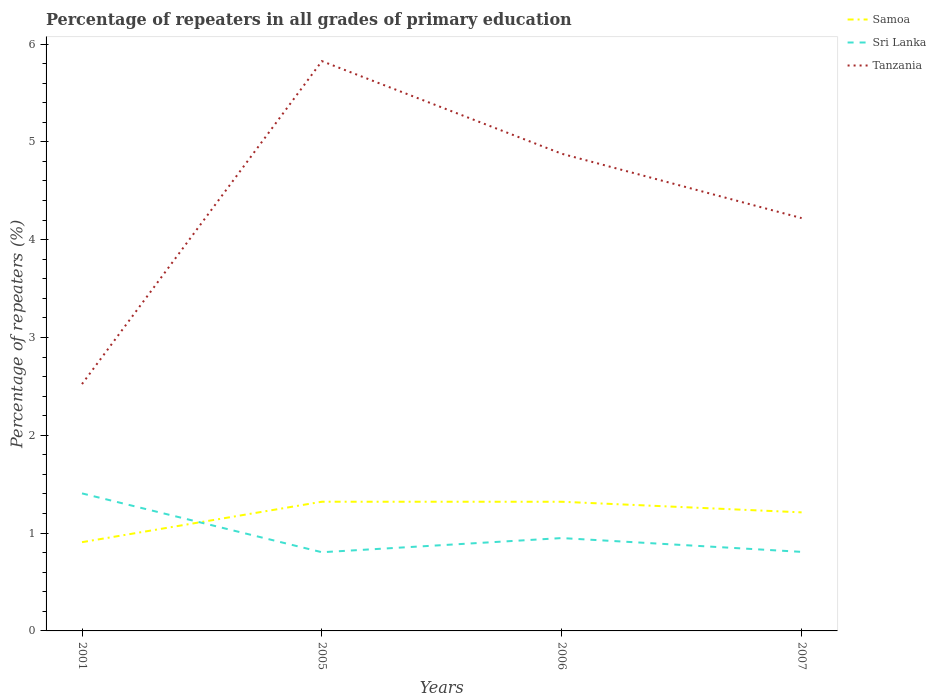How many different coloured lines are there?
Provide a short and direct response. 3. Across all years, what is the maximum percentage of repeaters in Sri Lanka?
Your answer should be very brief. 0.8. In which year was the percentage of repeaters in Samoa maximum?
Provide a succinct answer. 2001. What is the total percentage of repeaters in Tanzania in the graph?
Ensure brevity in your answer.  -1.7. What is the difference between the highest and the second highest percentage of repeaters in Sri Lanka?
Ensure brevity in your answer.  0.6. How many lines are there?
Make the answer very short. 3. How many years are there in the graph?
Your response must be concise. 4. What is the difference between two consecutive major ticks on the Y-axis?
Make the answer very short. 1. Does the graph contain grids?
Offer a terse response. No. How many legend labels are there?
Your answer should be very brief. 3. How are the legend labels stacked?
Your response must be concise. Vertical. What is the title of the graph?
Your answer should be very brief. Percentage of repeaters in all grades of primary education. Does "Guyana" appear as one of the legend labels in the graph?
Provide a short and direct response. No. What is the label or title of the X-axis?
Give a very brief answer. Years. What is the label or title of the Y-axis?
Ensure brevity in your answer.  Percentage of repeaters (%). What is the Percentage of repeaters (%) of Samoa in 2001?
Provide a short and direct response. 0.91. What is the Percentage of repeaters (%) of Sri Lanka in 2001?
Provide a succinct answer. 1.41. What is the Percentage of repeaters (%) in Tanzania in 2001?
Provide a short and direct response. 2.52. What is the Percentage of repeaters (%) in Samoa in 2005?
Ensure brevity in your answer.  1.32. What is the Percentage of repeaters (%) of Sri Lanka in 2005?
Make the answer very short. 0.8. What is the Percentage of repeaters (%) of Tanzania in 2005?
Make the answer very short. 5.83. What is the Percentage of repeaters (%) of Samoa in 2006?
Make the answer very short. 1.32. What is the Percentage of repeaters (%) of Sri Lanka in 2006?
Give a very brief answer. 0.95. What is the Percentage of repeaters (%) in Tanzania in 2006?
Ensure brevity in your answer.  4.88. What is the Percentage of repeaters (%) in Samoa in 2007?
Your response must be concise. 1.21. What is the Percentage of repeaters (%) in Sri Lanka in 2007?
Make the answer very short. 0.81. What is the Percentage of repeaters (%) in Tanzania in 2007?
Your answer should be compact. 4.22. Across all years, what is the maximum Percentage of repeaters (%) in Samoa?
Your answer should be very brief. 1.32. Across all years, what is the maximum Percentage of repeaters (%) of Sri Lanka?
Give a very brief answer. 1.41. Across all years, what is the maximum Percentage of repeaters (%) of Tanzania?
Ensure brevity in your answer.  5.83. Across all years, what is the minimum Percentage of repeaters (%) of Samoa?
Make the answer very short. 0.91. Across all years, what is the minimum Percentage of repeaters (%) in Sri Lanka?
Make the answer very short. 0.8. Across all years, what is the minimum Percentage of repeaters (%) in Tanzania?
Your answer should be very brief. 2.52. What is the total Percentage of repeaters (%) in Samoa in the graph?
Keep it short and to the point. 4.76. What is the total Percentage of repeaters (%) in Sri Lanka in the graph?
Your answer should be very brief. 3.97. What is the total Percentage of repeaters (%) of Tanzania in the graph?
Your answer should be very brief. 17.45. What is the difference between the Percentage of repeaters (%) in Samoa in 2001 and that in 2005?
Make the answer very short. -0.41. What is the difference between the Percentage of repeaters (%) of Sri Lanka in 2001 and that in 2005?
Your answer should be compact. 0.6. What is the difference between the Percentage of repeaters (%) of Tanzania in 2001 and that in 2005?
Provide a short and direct response. -3.3. What is the difference between the Percentage of repeaters (%) of Samoa in 2001 and that in 2006?
Provide a short and direct response. -0.41. What is the difference between the Percentage of repeaters (%) in Sri Lanka in 2001 and that in 2006?
Ensure brevity in your answer.  0.46. What is the difference between the Percentage of repeaters (%) in Tanzania in 2001 and that in 2006?
Offer a terse response. -2.35. What is the difference between the Percentage of repeaters (%) in Samoa in 2001 and that in 2007?
Give a very brief answer. -0.3. What is the difference between the Percentage of repeaters (%) of Sri Lanka in 2001 and that in 2007?
Provide a succinct answer. 0.6. What is the difference between the Percentage of repeaters (%) in Tanzania in 2001 and that in 2007?
Keep it short and to the point. -1.7. What is the difference between the Percentage of repeaters (%) of Samoa in 2005 and that in 2006?
Provide a succinct answer. 0. What is the difference between the Percentage of repeaters (%) of Sri Lanka in 2005 and that in 2006?
Offer a very short reply. -0.14. What is the difference between the Percentage of repeaters (%) in Tanzania in 2005 and that in 2006?
Ensure brevity in your answer.  0.95. What is the difference between the Percentage of repeaters (%) of Samoa in 2005 and that in 2007?
Make the answer very short. 0.11. What is the difference between the Percentage of repeaters (%) of Sri Lanka in 2005 and that in 2007?
Offer a very short reply. -0. What is the difference between the Percentage of repeaters (%) of Tanzania in 2005 and that in 2007?
Give a very brief answer. 1.6. What is the difference between the Percentage of repeaters (%) of Samoa in 2006 and that in 2007?
Give a very brief answer. 0.11. What is the difference between the Percentage of repeaters (%) of Sri Lanka in 2006 and that in 2007?
Provide a short and direct response. 0.14. What is the difference between the Percentage of repeaters (%) of Tanzania in 2006 and that in 2007?
Make the answer very short. 0.66. What is the difference between the Percentage of repeaters (%) of Samoa in 2001 and the Percentage of repeaters (%) of Sri Lanka in 2005?
Make the answer very short. 0.1. What is the difference between the Percentage of repeaters (%) in Samoa in 2001 and the Percentage of repeaters (%) in Tanzania in 2005?
Keep it short and to the point. -4.92. What is the difference between the Percentage of repeaters (%) in Sri Lanka in 2001 and the Percentage of repeaters (%) in Tanzania in 2005?
Your answer should be compact. -4.42. What is the difference between the Percentage of repeaters (%) of Samoa in 2001 and the Percentage of repeaters (%) of Sri Lanka in 2006?
Offer a terse response. -0.04. What is the difference between the Percentage of repeaters (%) in Samoa in 2001 and the Percentage of repeaters (%) in Tanzania in 2006?
Provide a succinct answer. -3.97. What is the difference between the Percentage of repeaters (%) of Sri Lanka in 2001 and the Percentage of repeaters (%) of Tanzania in 2006?
Keep it short and to the point. -3.47. What is the difference between the Percentage of repeaters (%) of Samoa in 2001 and the Percentage of repeaters (%) of Sri Lanka in 2007?
Your response must be concise. 0.1. What is the difference between the Percentage of repeaters (%) of Samoa in 2001 and the Percentage of repeaters (%) of Tanzania in 2007?
Keep it short and to the point. -3.31. What is the difference between the Percentage of repeaters (%) of Sri Lanka in 2001 and the Percentage of repeaters (%) of Tanzania in 2007?
Make the answer very short. -2.81. What is the difference between the Percentage of repeaters (%) in Samoa in 2005 and the Percentage of repeaters (%) in Sri Lanka in 2006?
Ensure brevity in your answer.  0.37. What is the difference between the Percentage of repeaters (%) of Samoa in 2005 and the Percentage of repeaters (%) of Tanzania in 2006?
Give a very brief answer. -3.56. What is the difference between the Percentage of repeaters (%) in Sri Lanka in 2005 and the Percentage of repeaters (%) in Tanzania in 2006?
Offer a very short reply. -4.07. What is the difference between the Percentage of repeaters (%) of Samoa in 2005 and the Percentage of repeaters (%) of Sri Lanka in 2007?
Give a very brief answer. 0.51. What is the difference between the Percentage of repeaters (%) of Samoa in 2005 and the Percentage of repeaters (%) of Tanzania in 2007?
Offer a very short reply. -2.9. What is the difference between the Percentage of repeaters (%) in Sri Lanka in 2005 and the Percentage of repeaters (%) in Tanzania in 2007?
Offer a very short reply. -3.42. What is the difference between the Percentage of repeaters (%) in Samoa in 2006 and the Percentage of repeaters (%) in Sri Lanka in 2007?
Provide a short and direct response. 0.51. What is the difference between the Percentage of repeaters (%) in Samoa in 2006 and the Percentage of repeaters (%) in Tanzania in 2007?
Offer a terse response. -2.9. What is the difference between the Percentage of repeaters (%) of Sri Lanka in 2006 and the Percentage of repeaters (%) of Tanzania in 2007?
Provide a succinct answer. -3.27. What is the average Percentage of repeaters (%) in Samoa per year?
Offer a terse response. 1.19. What is the average Percentage of repeaters (%) in Sri Lanka per year?
Offer a very short reply. 0.99. What is the average Percentage of repeaters (%) of Tanzania per year?
Your answer should be compact. 4.36. In the year 2001, what is the difference between the Percentage of repeaters (%) of Samoa and Percentage of repeaters (%) of Sri Lanka?
Offer a very short reply. -0.5. In the year 2001, what is the difference between the Percentage of repeaters (%) in Samoa and Percentage of repeaters (%) in Tanzania?
Ensure brevity in your answer.  -1.62. In the year 2001, what is the difference between the Percentage of repeaters (%) of Sri Lanka and Percentage of repeaters (%) of Tanzania?
Provide a succinct answer. -1.12. In the year 2005, what is the difference between the Percentage of repeaters (%) in Samoa and Percentage of repeaters (%) in Sri Lanka?
Offer a terse response. 0.52. In the year 2005, what is the difference between the Percentage of repeaters (%) in Samoa and Percentage of repeaters (%) in Tanzania?
Provide a succinct answer. -4.5. In the year 2005, what is the difference between the Percentage of repeaters (%) in Sri Lanka and Percentage of repeaters (%) in Tanzania?
Give a very brief answer. -5.02. In the year 2006, what is the difference between the Percentage of repeaters (%) in Samoa and Percentage of repeaters (%) in Sri Lanka?
Give a very brief answer. 0.37. In the year 2006, what is the difference between the Percentage of repeaters (%) of Samoa and Percentage of repeaters (%) of Tanzania?
Make the answer very short. -3.56. In the year 2006, what is the difference between the Percentage of repeaters (%) of Sri Lanka and Percentage of repeaters (%) of Tanzania?
Offer a very short reply. -3.93. In the year 2007, what is the difference between the Percentage of repeaters (%) in Samoa and Percentage of repeaters (%) in Sri Lanka?
Ensure brevity in your answer.  0.4. In the year 2007, what is the difference between the Percentage of repeaters (%) in Samoa and Percentage of repeaters (%) in Tanzania?
Your answer should be very brief. -3.01. In the year 2007, what is the difference between the Percentage of repeaters (%) in Sri Lanka and Percentage of repeaters (%) in Tanzania?
Your answer should be compact. -3.41. What is the ratio of the Percentage of repeaters (%) of Samoa in 2001 to that in 2005?
Offer a very short reply. 0.69. What is the ratio of the Percentage of repeaters (%) in Sri Lanka in 2001 to that in 2005?
Your response must be concise. 1.75. What is the ratio of the Percentage of repeaters (%) in Tanzania in 2001 to that in 2005?
Give a very brief answer. 0.43. What is the ratio of the Percentage of repeaters (%) of Samoa in 2001 to that in 2006?
Provide a short and direct response. 0.69. What is the ratio of the Percentage of repeaters (%) of Sri Lanka in 2001 to that in 2006?
Offer a very short reply. 1.48. What is the ratio of the Percentage of repeaters (%) in Tanzania in 2001 to that in 2006?
Your response must be concise. 0.52. What is the ratio of the Percentage of repeaters (%) of Samoa in 2001 to that in 2007?
Provide a short and direct response. 0.75. What is the ratio of the Percentage of repeaters (%) of Sri Lanka in 2001 to that in 2007?
Keep it short and to the point. 1.74. What is the ratio of the Percentage of repeaters (%) in Tanzania in 2001 to that in 2007?
Keep it short and to the point. 0.6. What is the ratio of the Percentage of repeaters (%) of Sri Lanka in 2005 to that in 2006?
Your answer should be compact. 0.85. What is the ratio of the Percentage of repeaters (%) in Tanzania in 2005 to that in 2006?
Keep it short and to the point. 1.19. What is the ratio of the Percentage of repeaters (%) of Samoa in 2005 to that in 2007?
Keep it short and to the point. 1.09. What is the ratio of the Percentage of repeaters (%) of Sri Lanka in 2005 to that in 2007?
Offer a very short reply. 1. What is the ratio of the Percentage of repeaters (%) in Tanzania in 2005 to that in 2007?
Make the answer very short. 1.38. What is the ratio of the Percentage of repeaters (%) in Samoa in 2006 to that in 2007?
Make the answer very short. 1.09. What is the ratio of the Percentage of repeaters (%) in Sri Lanka in 2006 to that in 2007?
Provide a short and direct response. 1.17. What is the ratio of the Percentage of repeaters (%) of Tanzania in 2006 to that in 2007?
Your answer should be compact. 1.16. What is the difference between the highest and the second highest Percentage of repeaters (%) of Sri Lanka?
Make the answer very short. 0.46. What is the difference between the highest and the second highest Percentage of repeaters (%) in Tanzania?
Provide a short and direct response. 0.95. What is the difference between the highest and the lowest Percentage of repeaters (%) of Samoa?
Your answer should be very brief. 0.41. What is the difference between the highest and the lowest Percentage of repeaters (%) of Sri Lanka?
Offer a terse response. 0.6. What is the difference between the highest and the lowest Percentage of repeaters (%) in Tanzania?
Provide a succinct answer. 3.3. 